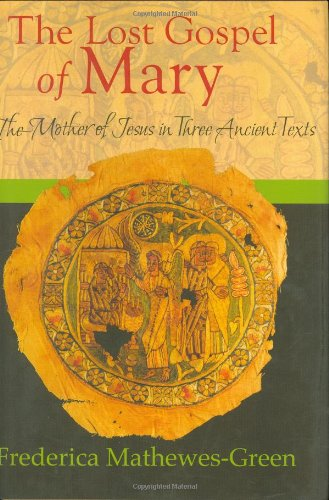What type of book is this? This is a book within the category 'Christian Books & Bibles'. It delves into Christian theological themes, particularly focusing on ancient texts about Mary, the mother of Jesus. 